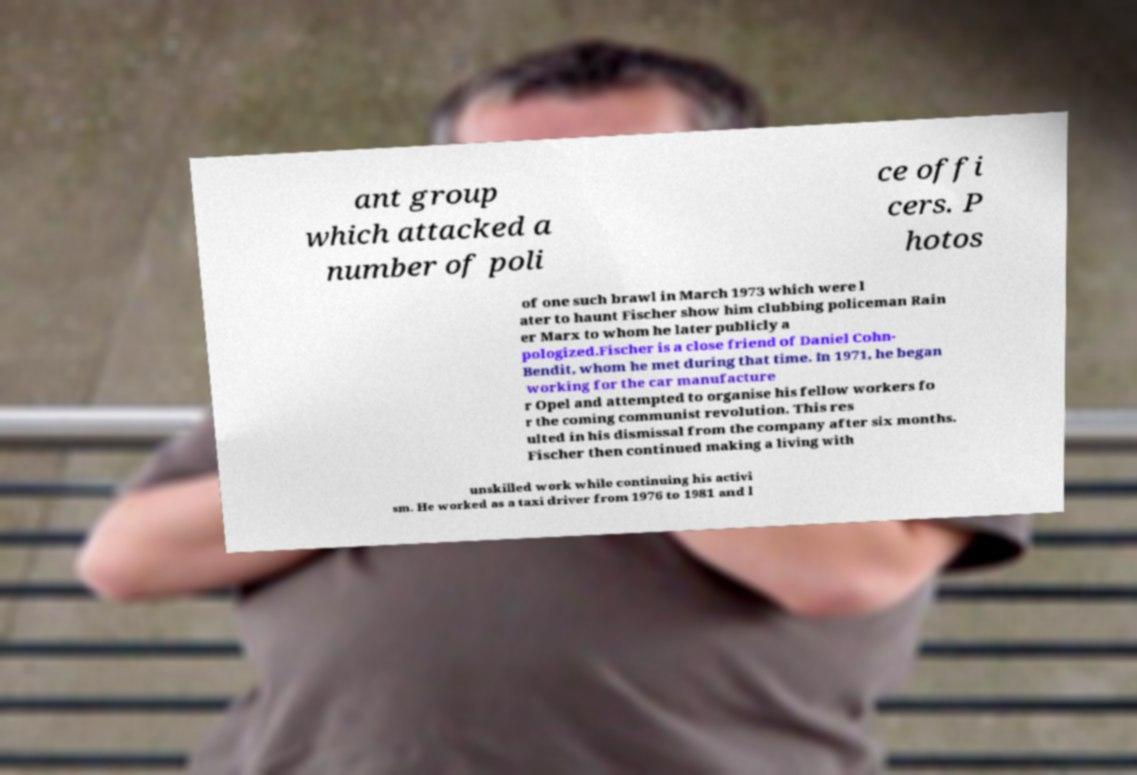Could you assist in decoding the text presented in this image and type it out clearly? ant group which attacked a number of poli ce offi cers. P hotos of one such brawl in March 1973 which were l ater to haunt Fischer show him clubbing policeman Rain er Marx to whom he later publicly a pologized.Fischer is a close friend of Daniel Cohn- Bendit, whom he met during that time. In 1971, he began working for the car manufacture r Opel and attempted to organise his fellow workers fo r the coming communist revolution. This res ulted in his dismissal from the company after six months. Fischer then continued making a living with unskilled work while continuing his activi sm. He worked as a taxi driver from 1976 to 1981 and l 